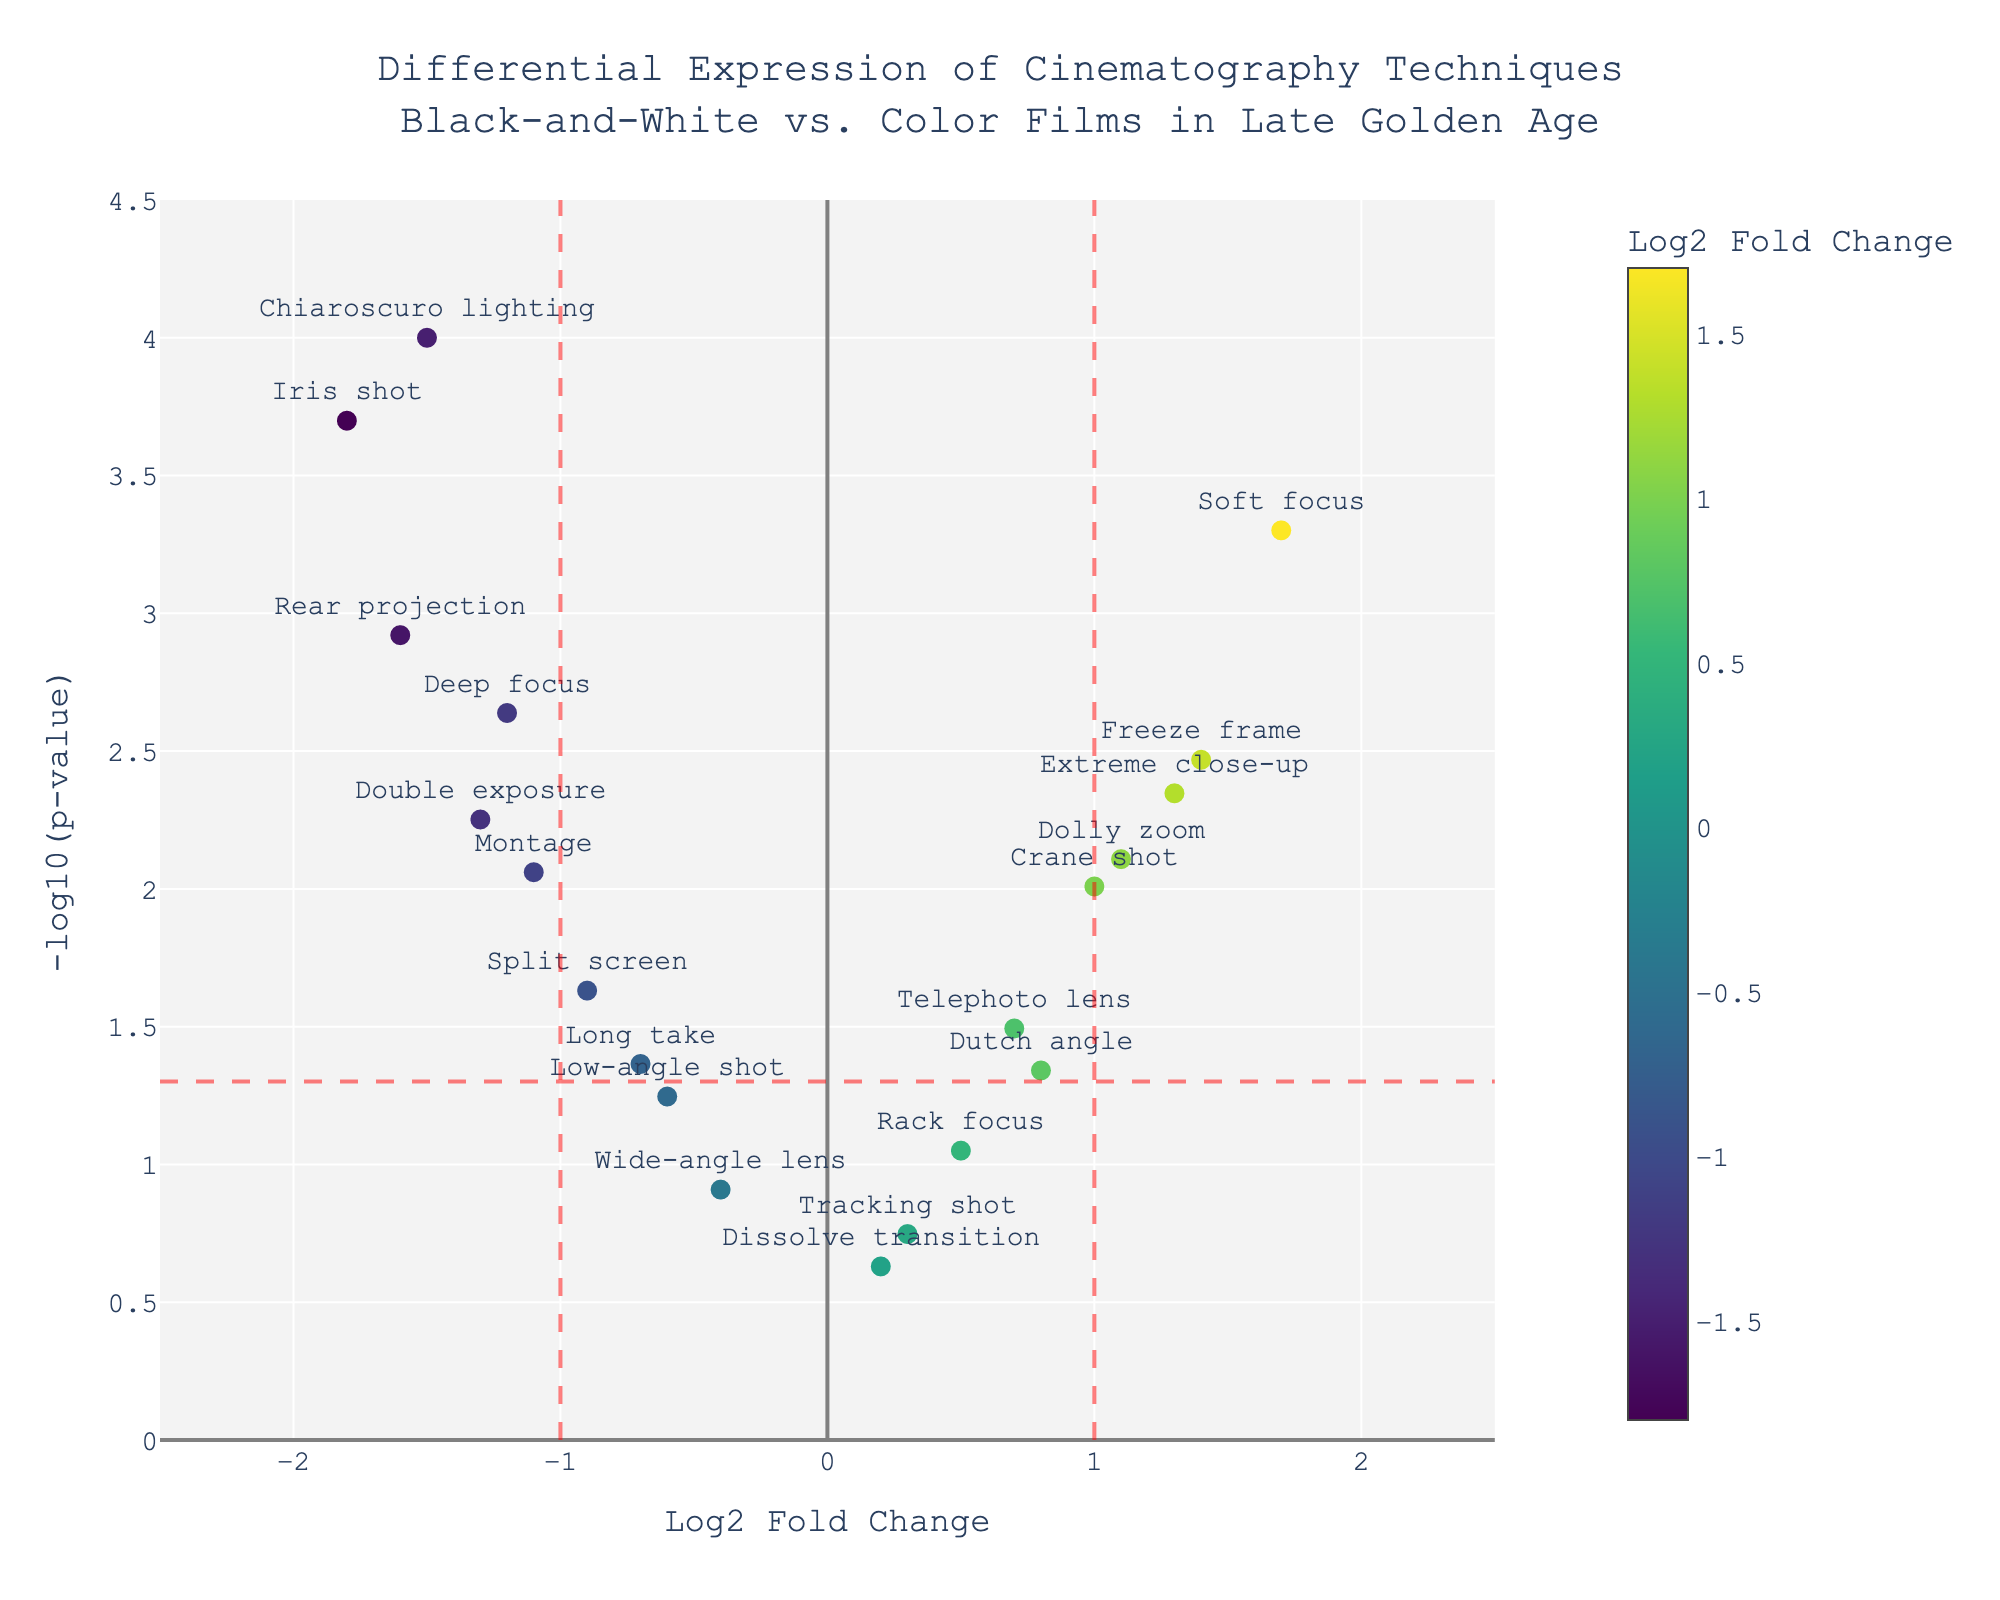What is the title of the figure? The title is usually found at the top of the figure. It describes the overall content or purpose of the chart. In this case, it states that the plot is about the "Differential Expression of Cinematography Techniques in Black-and-White vs. Color Films in Late Golden Age".
Answer: Differential Expression of Cinematography Techniques in Black-and-White vs. Color Films in Late Golden Age Which cinematography technique has the highest -log10(p-value)? To find this, look for the data point with the highest value on the vertical axis (-log10(p-value)). In this figure, "Chiaroscuro lighting" reaches the highest value.
Answer: Chiaroscuro lighting How many techniques have a Log2 Fold Change greater than 1? Identify points that are positioned to the right of the vertical line at Log2 Fold Change = 1. Count these points. Techniques include "Soft focus", "Dolly zoom", "Freeze frame", and "Extreme close-up".
Answer: 4 Which technique is closest to the threshold of statistical significance (horizontal red dashed line)? First, identify the horizontal red dashed line indicating the threshold of significance. Then, find the data point closest to this line. "Dutch angle" has a -log10(p-value) just slightly above this threshold.
Answer: Dutch angle Compare the Log2 Fold Change for "Deep focus" and "Soft focus". Which one is more significantly changed? Check the horizontal positions of "Deep focus" and "Soft focus". "Soft focus" has a Log2 Fold Change of 1.7 (positive), while "Deep focus" has -1.2 (negative). Look at the values, in absolute terms, "Soft focus" is larger.
Answer: Soft focus Are there more cinematography techniques with negative Log2 Fold Change or positive Log2 Fold Change? Count the points on the left side (negative) and right side (positive) of the vertical axis (Log2 Fold Change = 0). Techniques on the left include "Deep focus", "Chiaroscuro lighting", "Split screen", "Iris shot", "Long take", "Montage", "Rear projection", "Double exposure", and "Low-angle shot". The right side includes "Dutch angle", "Dolly zoom", "Soft focus", "Extreme close-up", "Telephoto lens", "Tracking shot", "Rack focus", "Crane shot", and "Dissolve transition".
Answer: Equal Which technique is furthest to the left on the Log2 Fold Change axis? Look at the data point positioned furthest to the left on the horizontal axis (Log2 Fold Change). "Iris shot" has the lowest Log2 Fold Change of -1.8.
Answer: Iris shot Which techniques fall within the not significantly changed region (-1 < Log2 Fold Change < 1) with a p-value > 0.05? Examine points in the middle region (within -1 and 1 on the Log2 Fold Change axis) and above the significance threshold on the vertical axis. Techniques include "Tracking shot", "Low-angle shot", "Rack focus", "Wide-angle lens", and "Dissolve transition".
Answer: Tracking shot, Low-angle shot, Rack focus, Wide-angle lens, Dissolve transition 